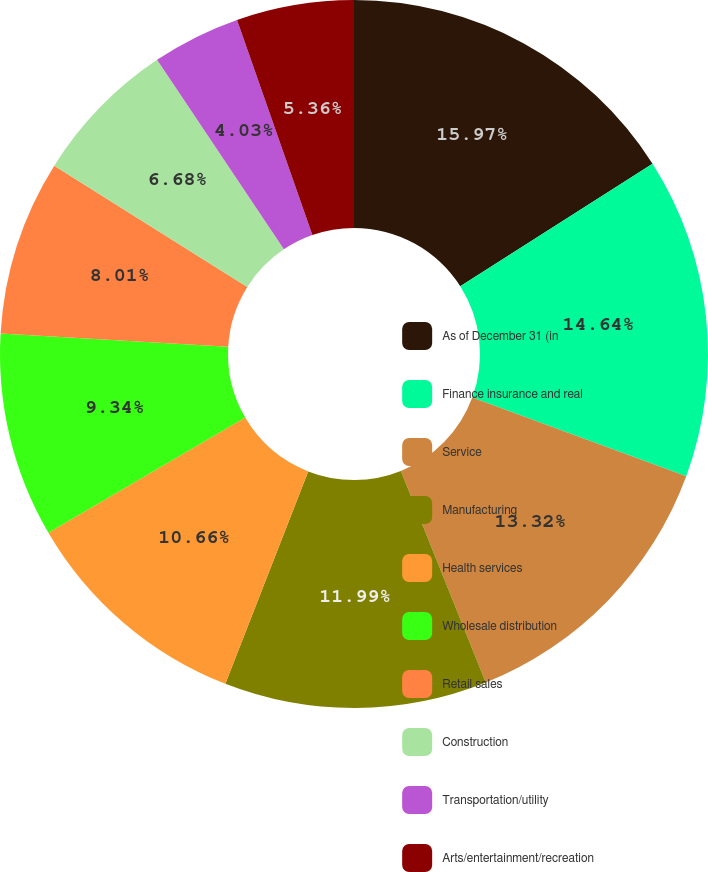Convert chart. <chart><loc_0><loc_0><loc_500><loc_500><pie_chart><fcel>As of December 31 (in<fcel>Finance insurance and real<fcel>Service<fcel>Manufacturing<fcel>Health services<fcel>Wholesale distribution<fcel>Retail sales<fcel>Construction<fcel>Transportation/utility<fcel>Arts/entertainment/recreation<nl><fcel>15.97%<fcel>14.64%<fcel>13.32%<fcel>11.99%<fcel>10.66%<fcel>9.34%<fcel>8.01%<fcel>6.68%<fcel>4.03%<fcel>5.36%<nl></chart> 